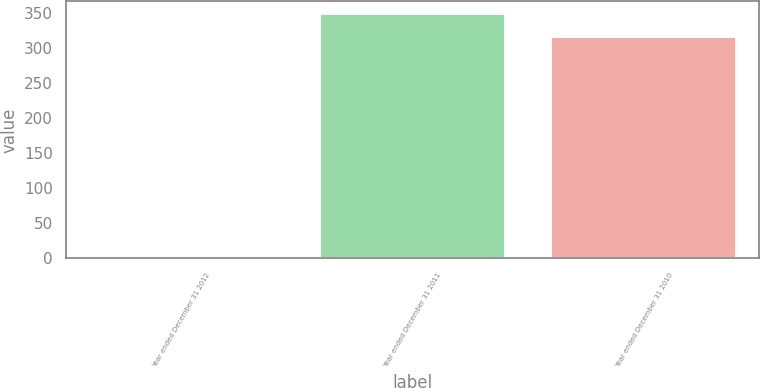Convert chart to OTSL. <chart><loc_0><loc_0><loc_500><loc_500><bar_chart><fcel>Year ended December 31 2012<fcel>Year ended December 31 2011<fcel>Year ended December 31 2010<nl><fcel>2.8<fcel>349.02<fcel>315<nl></chart> 